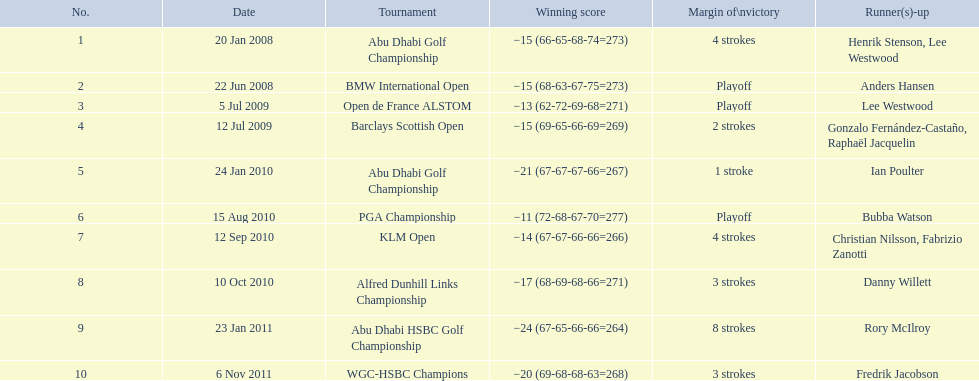What was the number of strokes for martin kaymer in the klm open? 4 strokes. What was the number of strokes in the abu dhabi golf championship? 4 strokes. How many extra strokes were there in the klm as opposed to the barclays open? 2 strokes. 